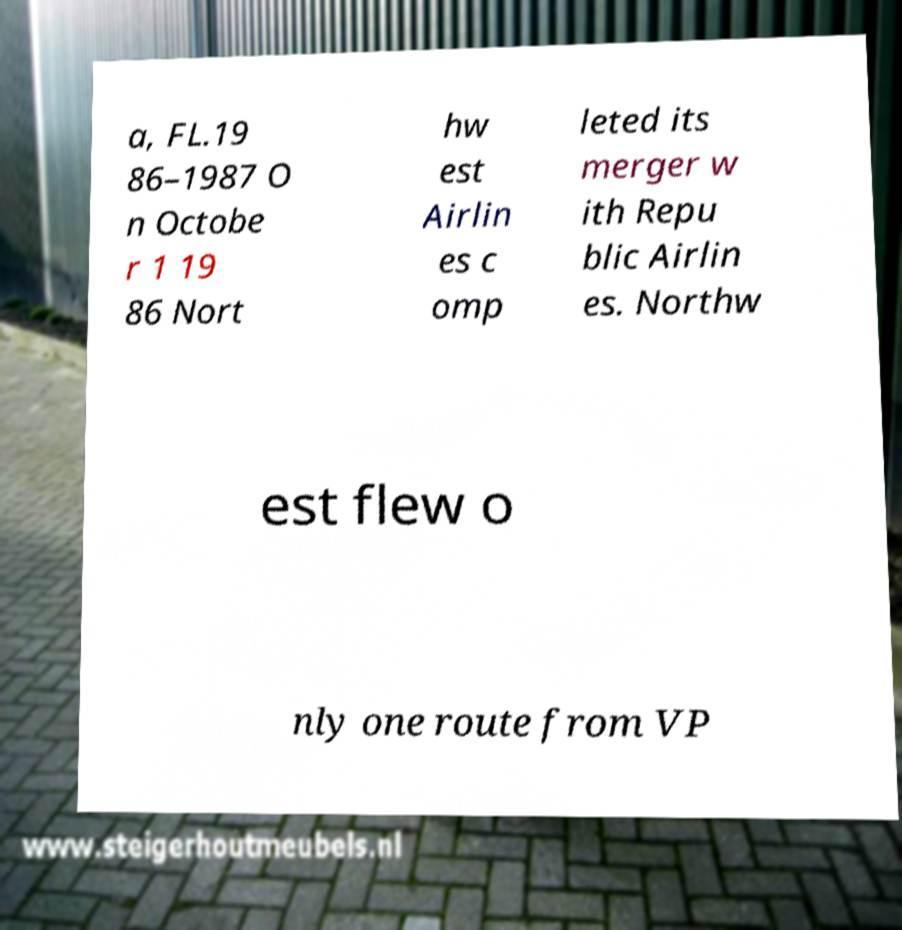Can you read and provide the text displayed in the image?This photo seems to have some interesting text. Can you extract and type it out for me? a, FL.19 86–1987 O n Octobe r 1 19 86 Nort hw est Airlin es c omp leted its merger w ith Repu blic Airlin es. Northw est flew o nly one route from VP 